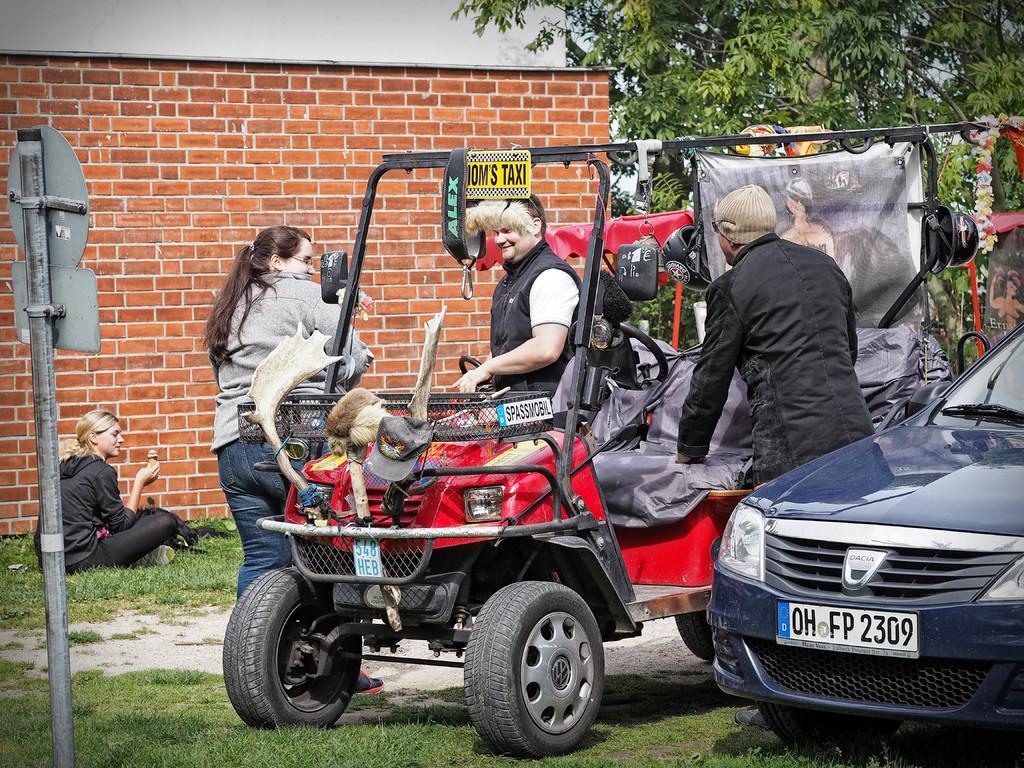Can you describe this image briefly? In this Image I see 2 vehicles and I see 4 persons in which this woman is sitting and rest of them are standing, I can also see there is a board on this pole and In the background I see the wall and the tree. 